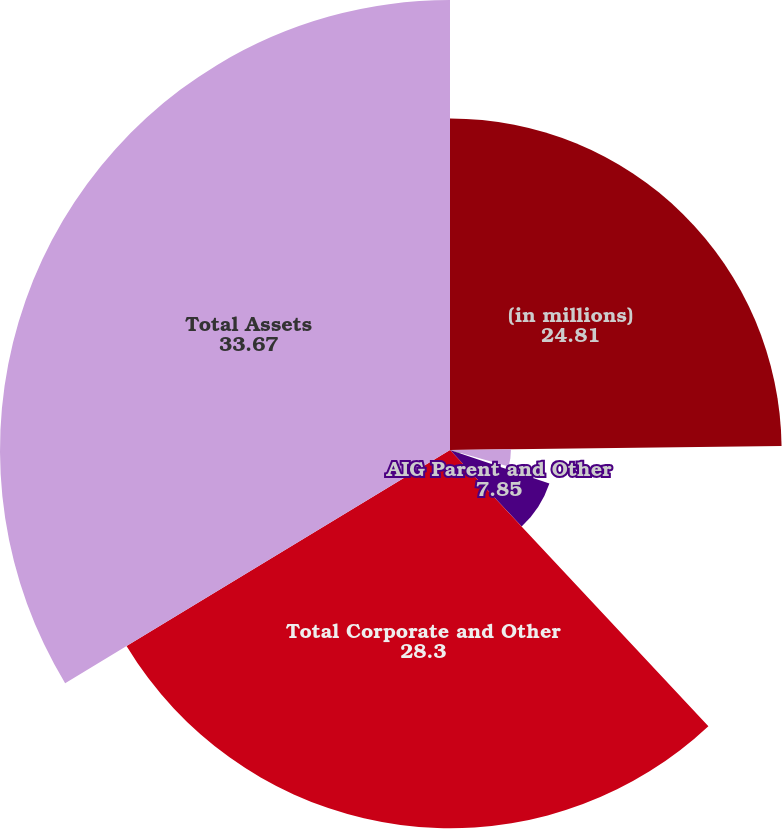<chart> <loc_0><loc_0><loc_500><loc_500><pie_chart><fcel>(in millions)<fcel>Total Non-Life Insurance<fcel>Total Life Insurance Companies<fcel>AIG Parent and Other<fcel>Total Corporate and Other<fcel>Total Assets<nl><fcel>24.81%<fcel>4.56%<fcel>0.81%<fcel>7.85%<fcel>28.3%<fcel>33.67%<nl></chart> 